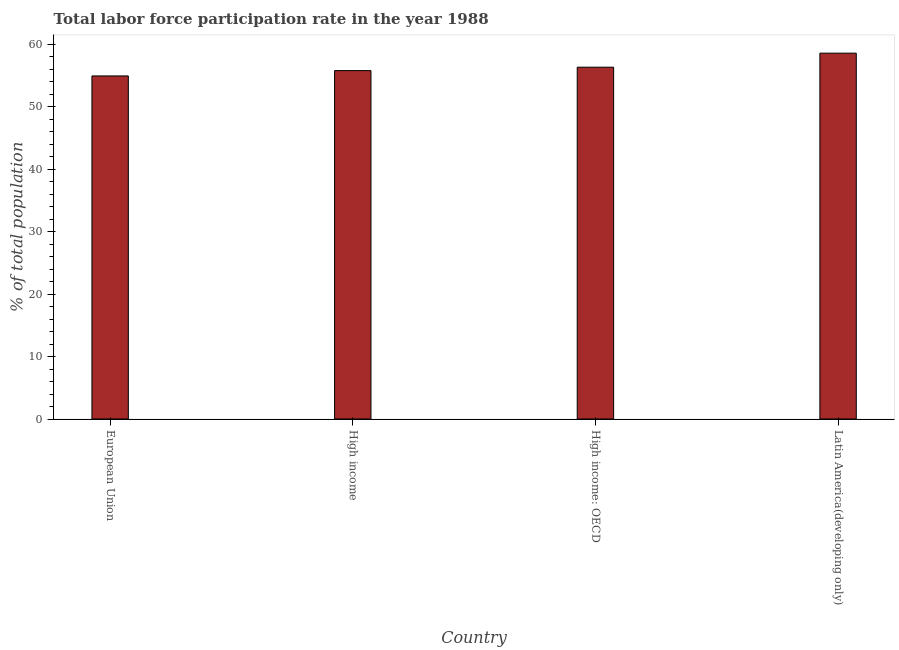Does the graph contain any zero values?
Offer a terse response. No. What is the title of the graph?
Offer a terse response. Total labor force participation rate in the year 1988. What is the label or title of the Y-axis?
Keep it short and to the point. % of total population. What is the total labor force participation rate in European Union?
Keep it short and to the point. 54.92. Across all countries, what is the maximum total labor force participation rate?
Keep it short and to the point. 58.56. Across all countries, what is the minimum total labor force participation rate?
Offer a very short reply. 54.92. In which country was the total labor force participation rate maximum?
Your answer should be very brief. Latin America(developing only). What is the sum of the total labor force participation rate?
Make the answer very short. 225.56. What is the difference between the total labor force participation rate in High income: OECD and Latin America(developing only)?
Keep it short and to the point. -2.25. What is the average total labor force participation rate per country?
Offer a terse response. 56.39. What is the median total labor force participation rate?
Keep it short and to the point. 56.04. In how many countries, is the total labor force participation rate greater than 58 %?
Your answer should be compact. 1. Is the total labor force participation rate in European Union less than that in High income: OECD?
Offer a very short reply. Yes. Is the difference between the total labor force participation rate in High income and Latin America(developing only) greater than the difference between any two countries?
Ensure brevity in your answer.  No. What is the difference between the highest and the second highest total labor force participation rate?
Offer a terse response. 2.25. Is the sum of the total labor force participation rate in European Union and High income: OECD greater than the maximum total labor force participation rate across all countries?
Your answer should be compact. Yes. What is the difference between the highest and the lowest total labor force participation rate?
Your answer should be very brief. 3.64. In how many countries, is the total labor force participation rate greater than the average total labor force participation rate taken over all countries?
Offer a terse response. 1. How many bars are there?
Your response must be concise. 4. Are all the bars in the graph horizontal?
Keep it short and to the point. No. What is the difference between two consecutive major ticks on the Y-axis?
Offer a very short reply. 10. What is the % of total population of European Union?
Your answer should be very brief. 54.92. What is the % of total population of High income?
Ensure brevity in your answer.  55.77. What is the % of total population in High income: OECD?
Your answer should be compact. 56.31. What is the % of total population in Latin America(developing only)?
Keep it short and to the point. 58.56. What is the difference between the % of total population in European Union and High income?
Provide a succinct answer. -0.85. What is the difference between the % of total population in European Union and High income: OECD?
Give a very brief answer. -1.4. What is the difference between the % of total population in European Union and Latin America(developing only)?
Give a very brief answer. -3.64. What is the difference between the % of total population in High income and High income: OECD?
Ensure brevity in your answer.  -0.55. What is the difference between the % of total population in High income and Latin America(developing only)?
Give a very brief answer. -2.79. What is the difference between the % of total population in High income: OECD and Latin America(developing only)?
Provide a short and direct response. -2.25. What is the ratio of the % of total population in European Union to that in High income: OECD?
Offer a terse response. 0.97. What is the ratio of the % of total population in European Union to that in Latin America(developing only)?
Make the answer very short. 0.94. What is the ratio of the % of total population in High income to that in High income: OECD?
Your response must be concise. 0.99. What is the ratio of the % of total population in High income to that in Latin America(developing only)?
Keep it short and to the point. 0.95. What is the ratio of the % of total population in High income: OECD to that in Latin America(developing only)?
Your response must be concise. 0.96. 